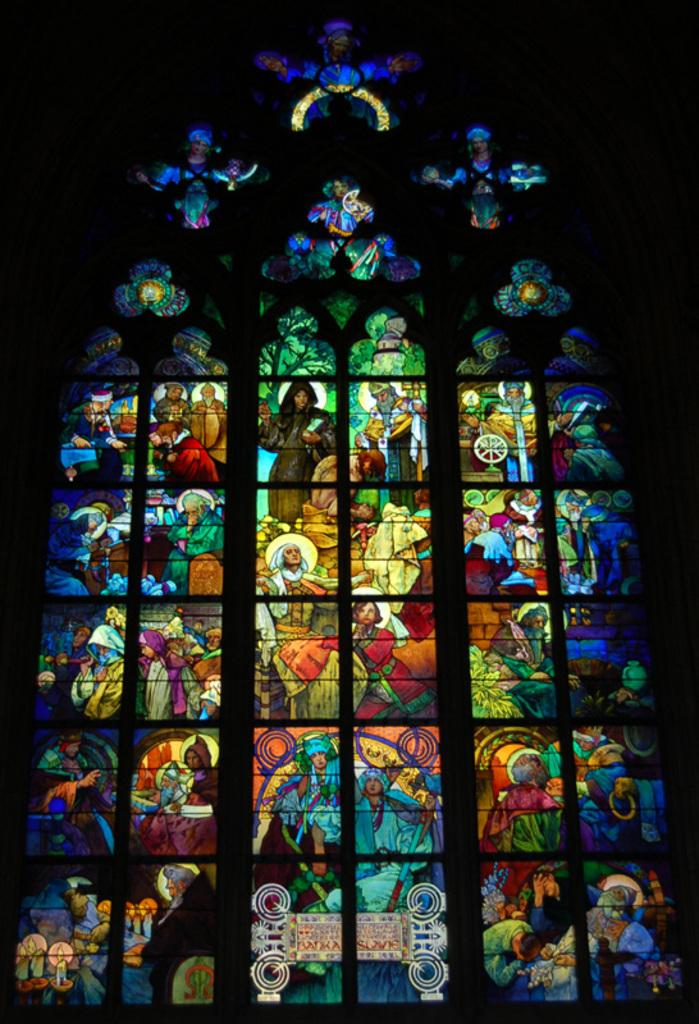What type of wall is visible in the image? There is a glass wall in the image. What can be seen on the glass wall? The glass wall has different images of different persons on it. How many rings are visible on the feet of the persons in the image? There are no rings or feet visible in the image; it only shows a glass wall with images of different persons. 